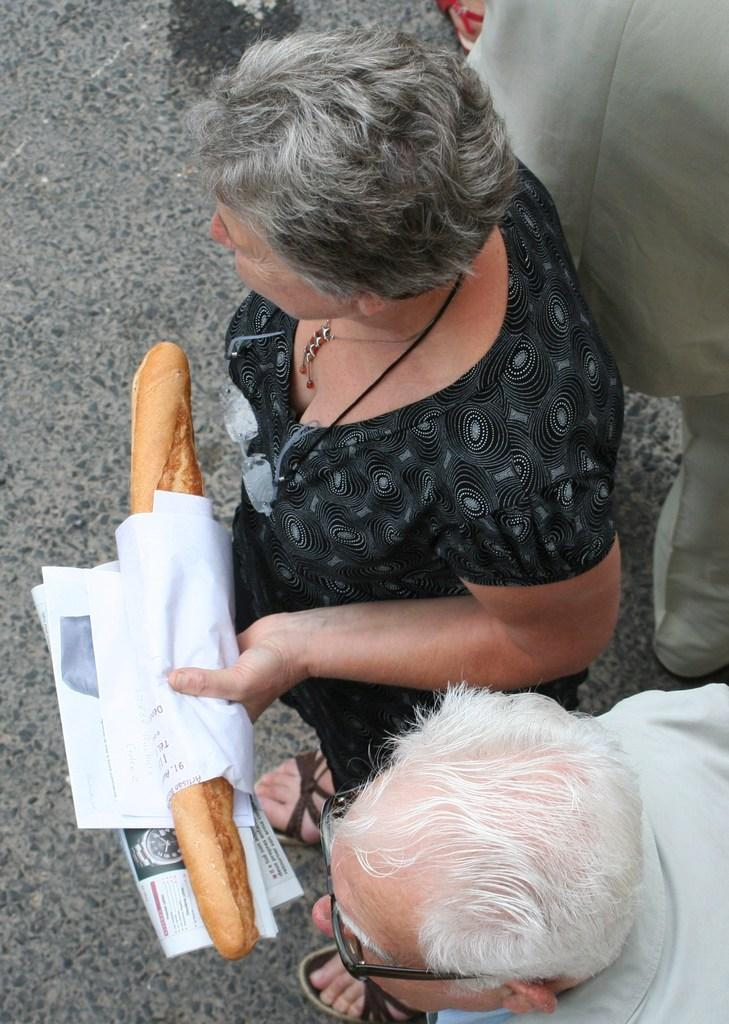How many people are present in the image? There are two people in the image. What are the people doing in the image? Both people are standing on the road. Can you describe one of the individuals in the image? One of the people is a woman. What is the woman holding in her hand? The woman is holding food in her hand. What type of mitten is the woman wearing in the image? There is no mitten present in the image; the woman is holding food in her hand. 